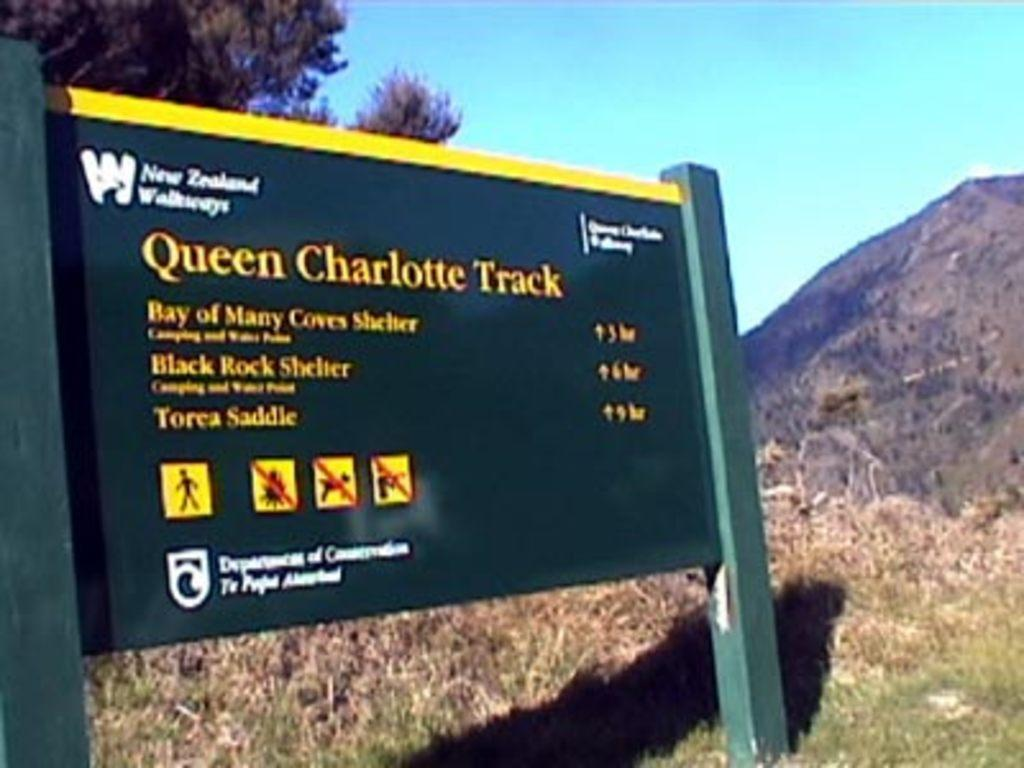What is the main object in the image? There is an information board in the image. What type of natural environment is visible in the image? There is grass, hills, and trees visible in the image. What part of the natural environment is not visible in the image? The image does not show any water bodies or bodies of water. What is visible in the sky in the image? The sky is visible in the image. What is the order of the queen in the image? There is no queen present in the image, so it is not possible to determine an order. 